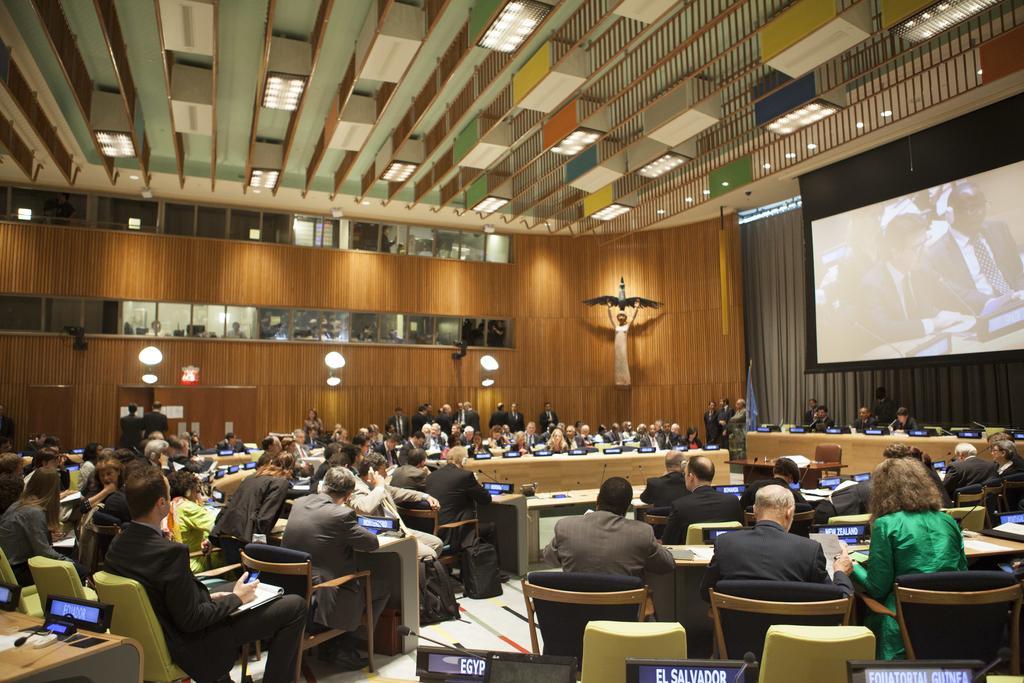In one or two sentences, can you explain what this image depicts? It seems to be the image inside of conference hall. In the image there are group of people sitting on chair in front of table, on table we can see a laptop,microphone,pen,paper,book. On right side we can see a screen and a curtain which is in grey color. In background there is some statue few lights,frames and roof on top. 